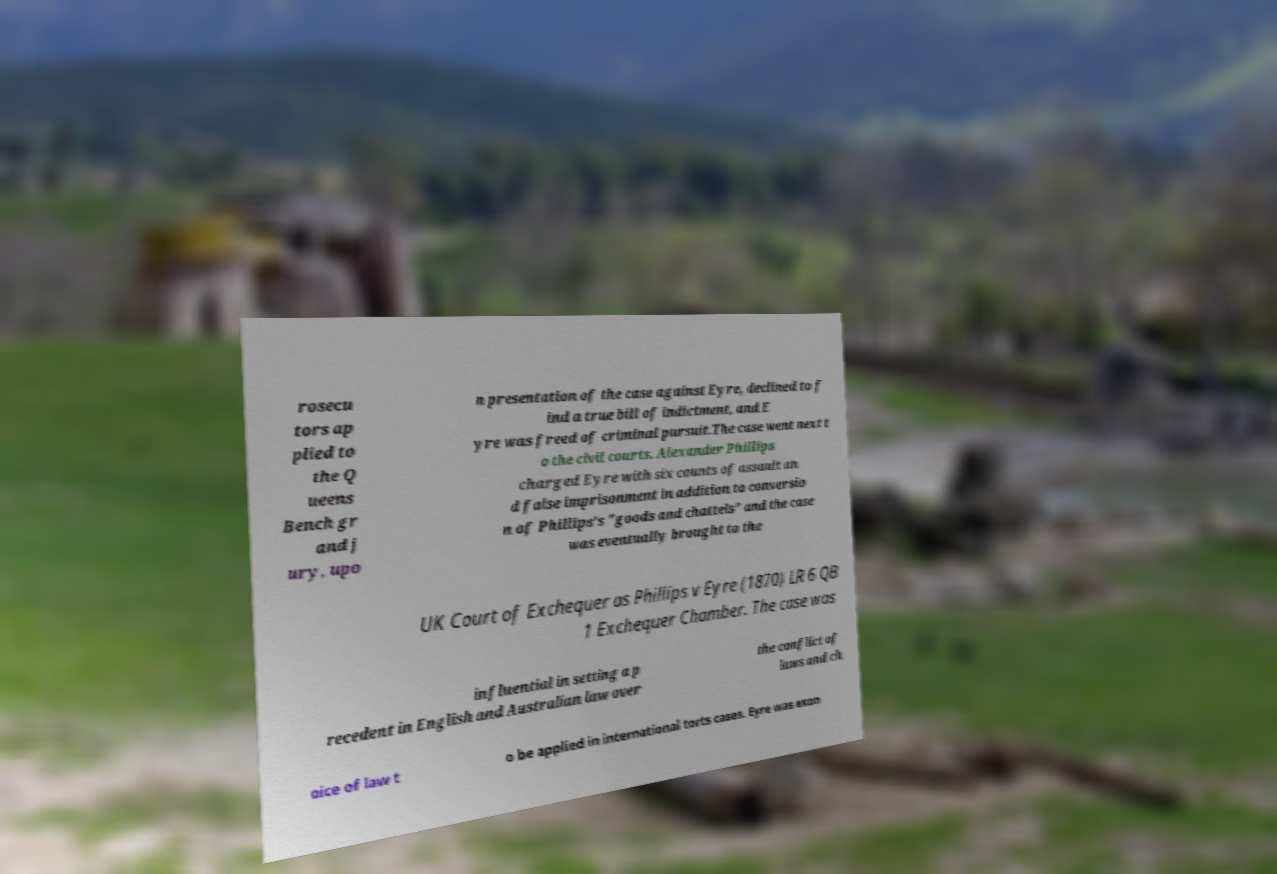Can you accurately transcribe the text from the provided image for me? rosecu tors ap plied to the Q ueens Bench gr and j ury, upo n presentation of the case against Eyre, declined to f ind a true bill of indictment, and E yre was freed of criminal pursuit.The case went next t o the civil courts. Alexander Phillips charged Eyre with six counts of assault an d false imprisonment in addition to conversio n of Phillips's "goods and chattels" and the case was eventually brought to the UK Court of Exchequer as Phillips v Eyre (1870) LR 6 QB 1 Exchequer Chamber. The case was influential in setting a p recedent in English and Australian law over the conflict of laws and ch oice of law t o be applied in international torts cases. Eyre was exon 